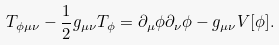Convert formula to latex. <formula><loc_0><loc_0><loc_500><loc_500>T _ { \phi \mu \nu } - \frac { 1 } { 2 } g _ { \mu \nu } T _ { \phi } = \partial _ { \mu } \phi \partial _ { \nu } \phi - g _ { \mu \nu } V [ \phi ] .</formula> 